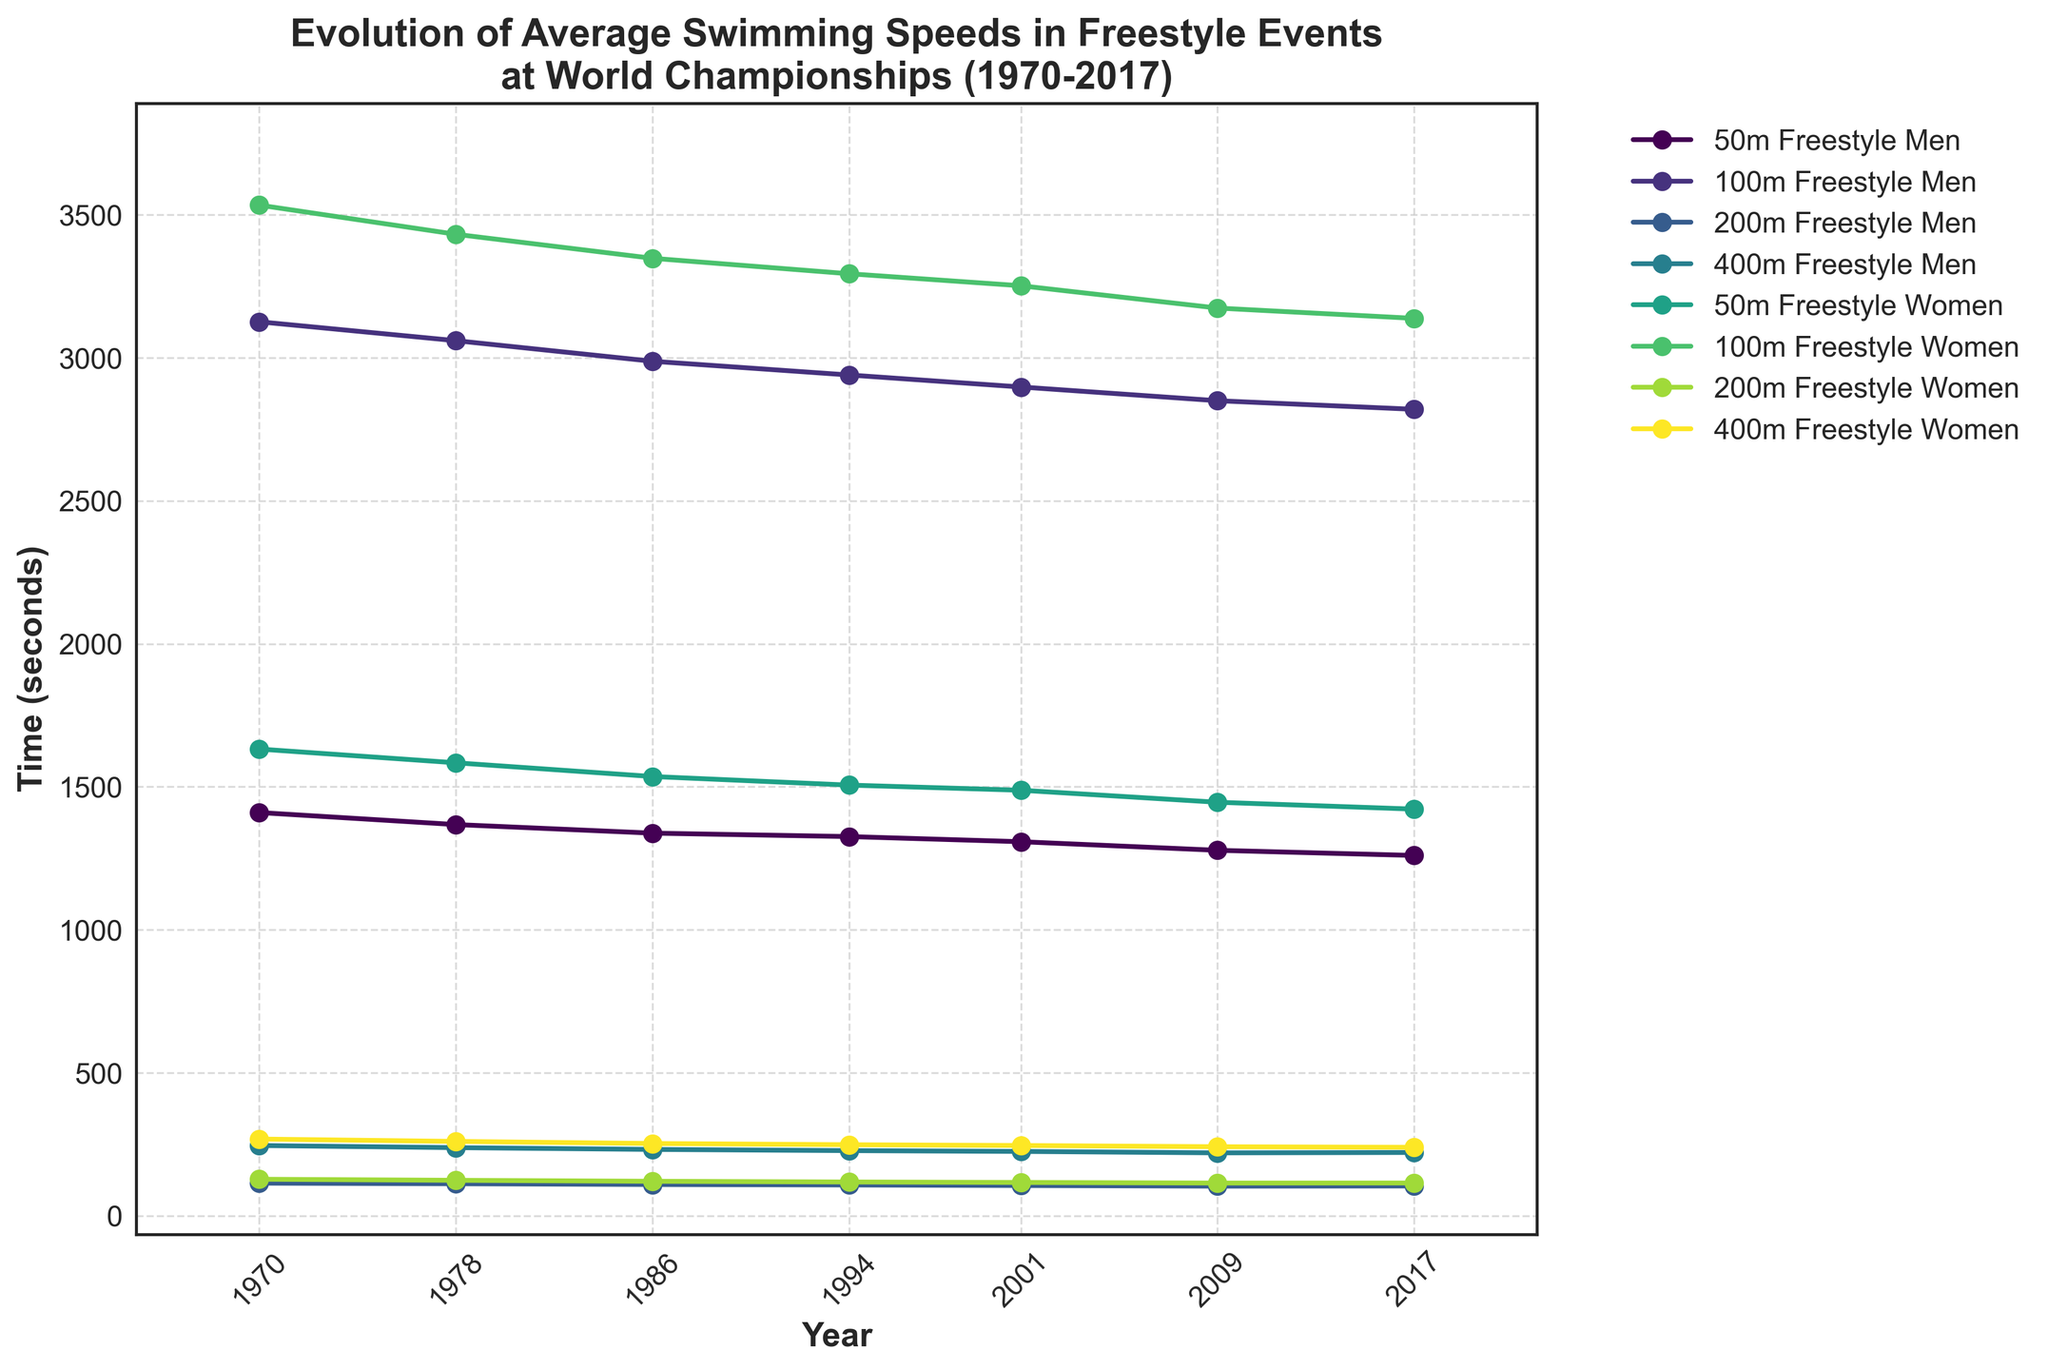Which men's event had the fastest average time in 2017? To find the fastest time, look at the 2017 values for all men's events. Compare the times: 50m Freestyle (21.0 secs), 100m Freestyle (47.0 secs), 200m Freestyle (104.3 secs), and 400m Freestyle (221.4 secs). The fastest time corresponds to the smallest value.
Answer: 50m Freestyle How much did the women's 100m freestyle time improve from 1970 to 2017? Check the 1970 and 2017 values for women's 100m Freestyle: 58.9 secs and 52.3 secs, respectively. Subtract the 2017 value from the 1970 value (58.9 - 52.3).
Answer: 6.6 secs What is the pattern of improvement in the men's 200m freestyle times from 1970 to 2009? Evaluate the times for men's 200m Freestyle: 1970 (114.2 secs), 1978 (112.1 secs), 1986 (109.5 secs), 1994 (107.8 secs), 2001 (105.9 secs), 2009 (103.7 secs). Observe the consistent decrease in times, indicating an improvement at each interval.
Answer: Consistent decrease What was the average time for women's 200m freestyle across all years presented? Add the times for all years in women's 200m Freestyle: 
127.8 + 124.1 + 120.7 + 118.2 + 116.6 + 114.5 + 114.7 = 836.6 secs. 
Divide by the number of years (7): 836.6 / 7.
Answer: 119.5 secs 